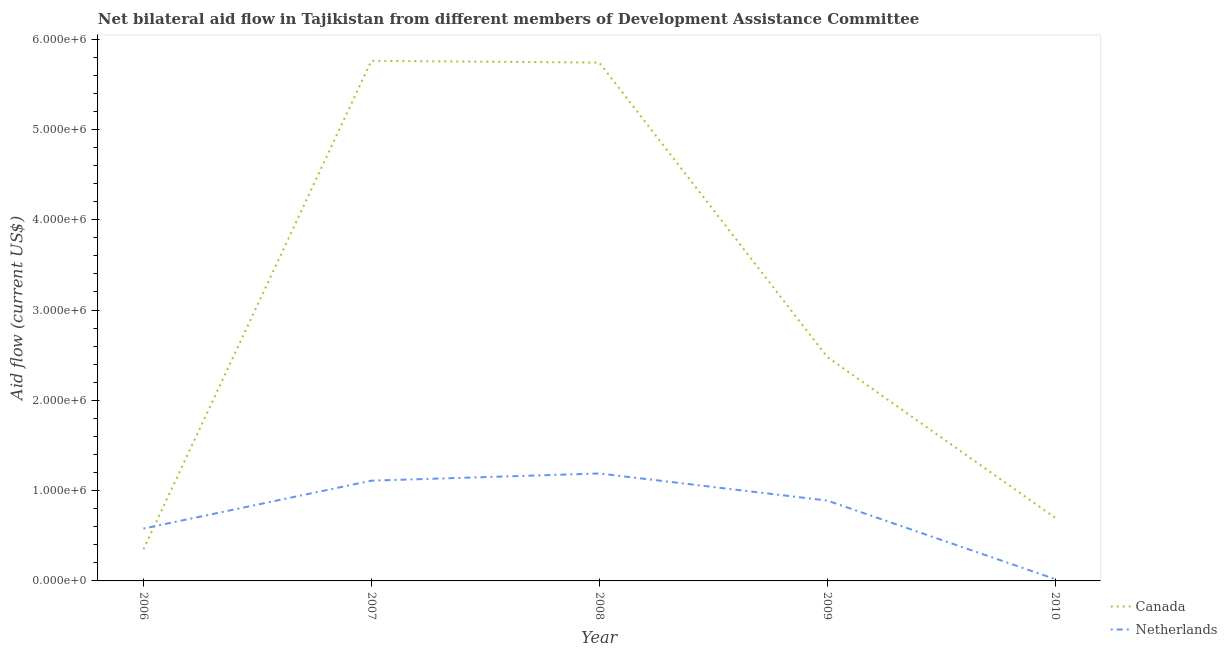How many different coloured lines are there?
Provide a succinct answer. 2. Does the line corresponding to amount of aid given by canada intersect with the line corresponding to amount of aid given by netherlands?
Provide a short and direct response. Yes. What is the amount of aid given by canada in 2007?
Keep it short and to the point. 5.76e+06. Across all years, what is the maximum amount of aid given by netherlands?
Give a very brief answer. 1.19e+06. Across all years, what is the minimum amount of aid given by netherlands?
Make the answer very short. 2.00e+04. In which year was the amount of aid given by canada minimum?
Keep it short and to the point. 2006. What is the total amount of aid given by netherlands in the graph?
Make the answer very short. 3.79e+06. What is the difference between the amount of aid given by canada in 2008 and that in 2009?
Keep it short and to the point. 3.26e+06. What is the difference between the amount of aid given by netherlands in 2006 and the amount of aid given by canada in 2008?
Offer a very short reply. -5.16e+06. What is the average amount of aid given by canada per year?
Your answer should be very brief. 3.01e+06. In the year 2008, what is the difference between the amount of aid given by canada and amount of aid given by netherlands?
Give a very brief answer. 4.55e+06. What is the ratio of the amount of aid given by canada in 2006 to that in 2008?
Offer a terse response. 0.06. What is the difference between the highest and the second highest amount of aid given by netherlands?
Your response must be concise. 8.00e+04. What is the difference between the highest and the lowest amount of aid given by canada?
Offer a terse response. 5.41e+06. In how many years, is the amount of aid given by canada greater than the average amount of aid given by canada taken over all years?
Ensure brevity in your answer.  2. Does the amount of aid given by canada monotonically increase over the years?
Your response must be concise. No. Is the amount of aid given by canada strictly less than the amount of aid given by netherlands over the years?
Provide a succinct answer. No. How many lines are there?
Provide a succinct answer. 2. How many years are there in the graph?
Your answer should be compact. 5. Does the graph contain any zero values?
Offer a very short reply. No. Where does the legend appear in the graph?
Keep it short and to the point. Bottom right. How many legend labels are there?
Offer a terse response. 2. How are the legend labels stacked?
Offer a terse response. Vertical. What is the title of the graph?
Offer a terse response. Net bilateral aid flow in Tajikistan from different members of Development Assistance Committee. What is the label or title of the X-axis?
Ensure brevity in your answer.  Year. What is the label or title of the Y-axis?
Offer a terse response. Aid flow (current US$). What is the Aid flow (current US$) in Netherlands in 2006?
Your answer should be compact. 5.80e+05. What is the Aid flow (current US$) of Canada in 2007?
Your answer should be very brief. 5.76e+06. What is the Aid flow (current US$) in Netherlands in 2007?
Give a very brief answer. 1.11e+06. What is the Aid flow (current US$) of Canada in 2008?
Offer a very short reply. 5.74e+06. What is the Aid flow (current US$) of Netherlands in 2008?
Provide a short and direct response. 1.19e+06. What is the Aid flow (current US$) of Canada in 2009?
Offer a very short reply. 2.48e+06. What is the Aid flow (current US$) of Netherlands in 2009?
Your answer should be compact. 8.90e+05. Across all years, what is the maximum Aid flow (current US$) of Canada?
Your answer should be compact. 5.76e+06. Across all years, what is the maximum Aid flow (current US$) of Netherlands?
Provide a short and direct response. 1.19e+06. Across all years, what is the minimum Aid flow (current US$) of Canada?
Your response must be concise. 3.50e+05. What is the total Aid flow (current US$) in Canada in the graph?
Your answer should be very brief. 1.50e+07. What is the total Aid flow (current US$) of Netherlands in the graph?
Keep it short and to the point. 3.79e+06. What is the difference between the Aid flow (current US$) in Canada in 2006 and that in 2007?
Keep it short and to the point. -5.41e+06. What is the difference between the Aid flow (current US$) of Netherlands in 2006 and that in 2007?
Provide a short and direct response. -5.30e+05. What is the difference between the Aid flow (current US$) in Canada in 2006 and that in 2008?
Keep it short and to the point. -5.39e+06. What is the difference between the Aid flow (current US$) of Netherlands in 2006 and that in 2008?
Your answer should be compact. -6.10e+05. What is the difference between the Aid flow (current US$) of Canada in 2006 and that in 2009?
Provide a short and direct response. -2.13e+06. What is the difference between the Aid flow (current US$) of Netherlands in 2006 and that in 2009?
Your answer should be very brief. -3.10e+05. What is the difference between the Aid flow (current US$) in Canada in 2006 and that in 2010?
Your answer should be compact. -3.50e+05. What is the difference between the Aid flow (current US$) of Netherlands in 2006 and that in 2010?
Ensure brevity in your answer.  5.60e+05. What is the difference between the Aid flow (current US$) in Canada in 2007 and that in 2009?
Make the answer very short. 3.28e+06. What is the difference between the Aid flow (current US$) in Netherlands in 2007 and that in 2009?
Provide a short and direct response. 2.20e+05. What is the difference between the Aid flow (current US$) of Canada in 2007 and that in 2010?
Make the answer very short. 5.06e+06. What is the difference between the Aid flow (current US$) in Netherlands in 2007 and that in 2010?
Ensure brevity in your answer.  1.09e+06. What is the difference between the Aid flow (current US$) in Canada in 2008 and that in 2009?
Keep it short and to the point. 3.26e+06. What is the difference between the Aid flow (current US$) in Netherlands in 2008 and that in 2009?
Ensure brevity in your answer.  3.00e+05. What is the difference between the Aid flow (current US$) in Canada in 2008 and that in 2010?
Keep it short and to the point. 5.04e+06. What is the difference between the Aid flow (current US$) of Netherlands in 2008 and that in 2010?
Give a very brief answer. 1.17e+06. What is the difference between the Aid flow (current US$) of Canada in 2009 and that in 2010?
Give a very brief answer. 1.78e+06. What is the difference between the Aid flow (current US$) of Netherlands in 2009 and that in 2010?
Your response must be concise. 8.70e+05. What is the difference between the Aid flow (current US$) of Canada in 2006 and the Aid flow (current US$) of Netherlands in 2007?
Offer a very short reply. -7.60e+05. What is the difference between the Aid flow (current US$) of Canada in 2006 and the Aid flow (current US$) of Netherlands in 2008?
Ensure brevity in your answer.  -8.40e+05. What is the difference between the Aid flow (current US$) of Canada in 2006 and the Aid flow (current US$) of Netherlands in 2009?
Keep it short and to the point. -5.40e+05. What is the difference between the Aid flow (current US$) of Canada in 2006 and the Aid flow (current US$) of Netherlands in 2010?
Give a very brief answer. 3.30e+05. What is the difference between the Aid flow (current US$) in Canada in 2007 and the Aid flow (current US$) in Netherlands in 2008?
Offer a terse response. 4.57e+06. What is the difference between the Aid flow (current US$) of Canada in 2007 and the Aid flow (current US$) of Netherlands in 2009?
Your answer should be compact. 4.87e+06. What is the difference between the Aid flow (current US$) in Canada in 2007 and the Aid flow (current US$) in Netherlands in 2010?
Provide a succinct answer. 5.74e+06. What is the difference between the Aid flow (current US$) of Canada in 2008 and the Aid flow (current US$) of Netherlands in 2009?
Offer a terse response. 4.85e+06. What is the difference between the Aid flow (current US$) in Canada in 2008 and the Aid flow (current US$) in Netherlands in 2010?
Ensure brevity in your answer.  5.72e+06. What is the difference between the Aid flow (current US$) in Canada in 2009 and the Aid flow (current US$) in Netherlands in 2010?
Ensure brevity in your answer.  2.46e+06. What is the average Aid flow (current US$) in Canada per year?
Your answer should be very brief. 3.01e+06. What is the average Aid flow (current US$) of Netherlands per year?
Offer a terse response. 7.58e+05. In the year 2006, what is the difference between the Aid flow (current US$) in Canada and Aid flow (current US$) in Netherlands?
Make the answer very short. -2.30e+05. In the year 2007, what is the difference between the Aid flow (current US$) in Canada and Aid flow (current US$) in Netherlands?
Keep it short and to the point. 4.65e+06. In the year 2008, what is the difference between the Aid flow (current US$) of Canada and Aid flow (current US$) of Netherlands?
Offer a terse response. 4.55e+06. In the year 2009, what is the difference between the Aid flow (current US$) in Canada and Aid flow (current US$) in Netherlands?
Give a very brief answer. 1.59e+06. In the year 2010, what is the difference between the Aid flow (current US$) in Canada and Aid flow (current US$) in Netherlands?
Make the answer very short. 6.80e+05. What is the ratio of the Aid flow (current US$) in Canada in 2006 to that in 2007?
Your response must be concise. 0.06. What is the ratio of the Aid flow (current US$) of Netherlands in 2006 to that in 2007?
Your response must be concise. 0.52. What is the ratio of the Aid flow (current US$) in Canada in 2006 to that in 2008?
Ensure brevity in your answer.  0.06. What is the ratio of the Aid flow (current US$) of Netherlands in 2006 to that in 2008?
Your response must be concise. 0.49. What is the ratio of the Aid flow (current US$) of Canada in 2006 to that in 2009?
Keep it short and to the point. 0.14. What is the ratio of the Aid flow (current US$) of Netherlands in 2006 to that in 2009?
Ensure brevity in your answer.  0.65. What is the ratio of the Aid flow (current US$) in Canada in 2007 to that in 2008?
Your answer should be compact. 1. What is the ratio of the Aid flow (current US$) in Netherlands in 2007 to that in 2008?
Ensure brevity in your answer.  0.93. What is the ratio of the Aid flow (current US$) in Canada in 2007 to that in 2009?
Provide a succinct answer. 2.32. What is the ratio of the Aid flow (current US$) in Netherlands in 2007 to that in 2009?
Ensure brevity in your answer.  1.25. What is the ratio of the Aid flow (current US$) of Canada in 2007 to that in 2010?
Give a very brief answer. 8.23. What is the ratio of the Aid flow (current US$) of Netherlands in 2007 to that in 2010?
Keep it short and to the point. 55.5. What is the ratio of the Aid flow (current US$) of Canada in 2008 to that in 2009?
Offer a very short reply. 2.31. What is the ratio of the Aid flow (current US$) in Netherlands in 2008 to that in 2009?
Ensure brevity in your answer.  1.34. What is the ratio of the Aid flow (current US$) in Canada in 2008 to that in 2010?
Your answer should be compact. 8.2. What is the ratio of the Aid flow (current US$) of Netherlands in 2008 to that in 2010?
Keep it short and to the point. 59.5. What is the ratio of the Aid flow (current US$) in Canada in 2009 to that in 2010?
Your answer should be very brief. 3.54. What is the ratio of the Aid flow (current US$) in Netherlands in 2009 to that in 2010?
Make the answer very short. 44.5. What is the difference between the highest and the second highest Aid flow (current US$) in Netherlands?
Provide a short and direct response. 8.00e+04. What is the difference between the highest and the lowest Aid flow (current US$) in Canada?
Offer a terse response. 5.41e+06. What is the difference between the highest and the lowest Aid flow (current US$) of Netherlands?
Provide a short and direct response. 1.17e+06. 